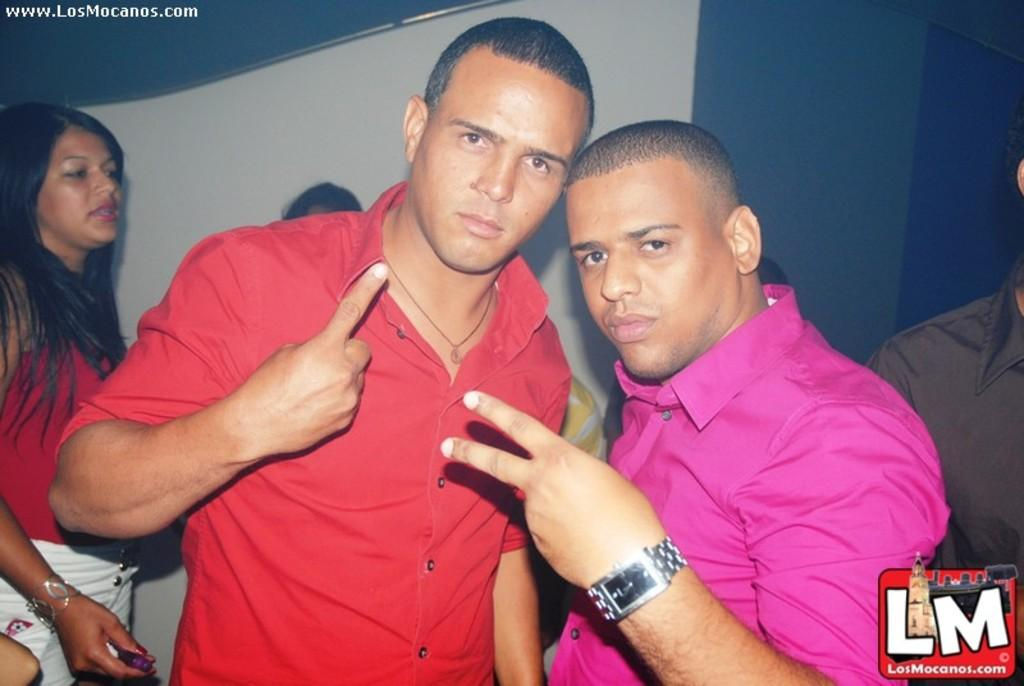How many people are in the image? There are three people in the image: a man, another man, and a woman. What is the man wearing on the right side of the image? The man is wearing a pink shirt. What is the second man doing in the image? The second man is showing his index finger. What is the second man wearing in the image? The second man is wearing a red shirt. Where is the woman located in the image? The woman is on the left side of the image. What time of day is it in the image, given the presence of a skate? There is no skate present in the image, so it is not possible to determine the time of day based on that information. 